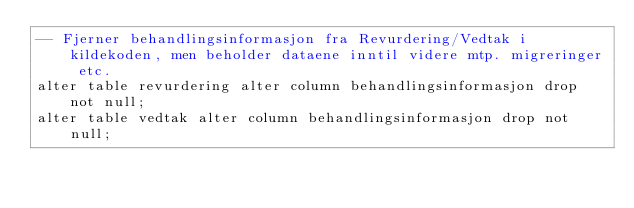<code> <loc_0><loc_0><loc_500><loc_500><_SQL_>-- Fjerner behandlingsinformasjon fra Revurdering/Vedtak i kildekoden, men beholder dataene inntil videre mtp. migreringer etc.
alter table revurdering alter column behandlingsinformasjon drop not null;
alter table vedtak alter column behandlingsinformasjon drop not null;</code> 